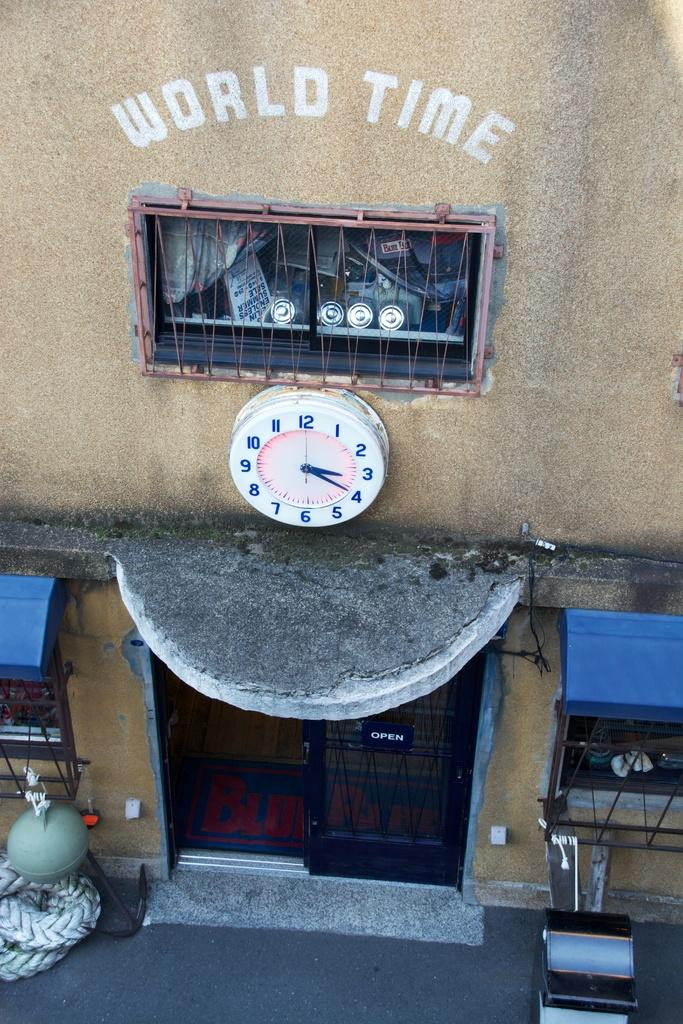<image>
Relay a brief, clear account of the picture shown. A clock with the words world time written on the wall above it. 